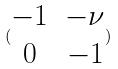<formula> <loc_0><loc_0><loc_500><loc_500>( \begin{matrix} - 1 & - \nu \\ 0 & - 1 \end{matrix} )</formula> 